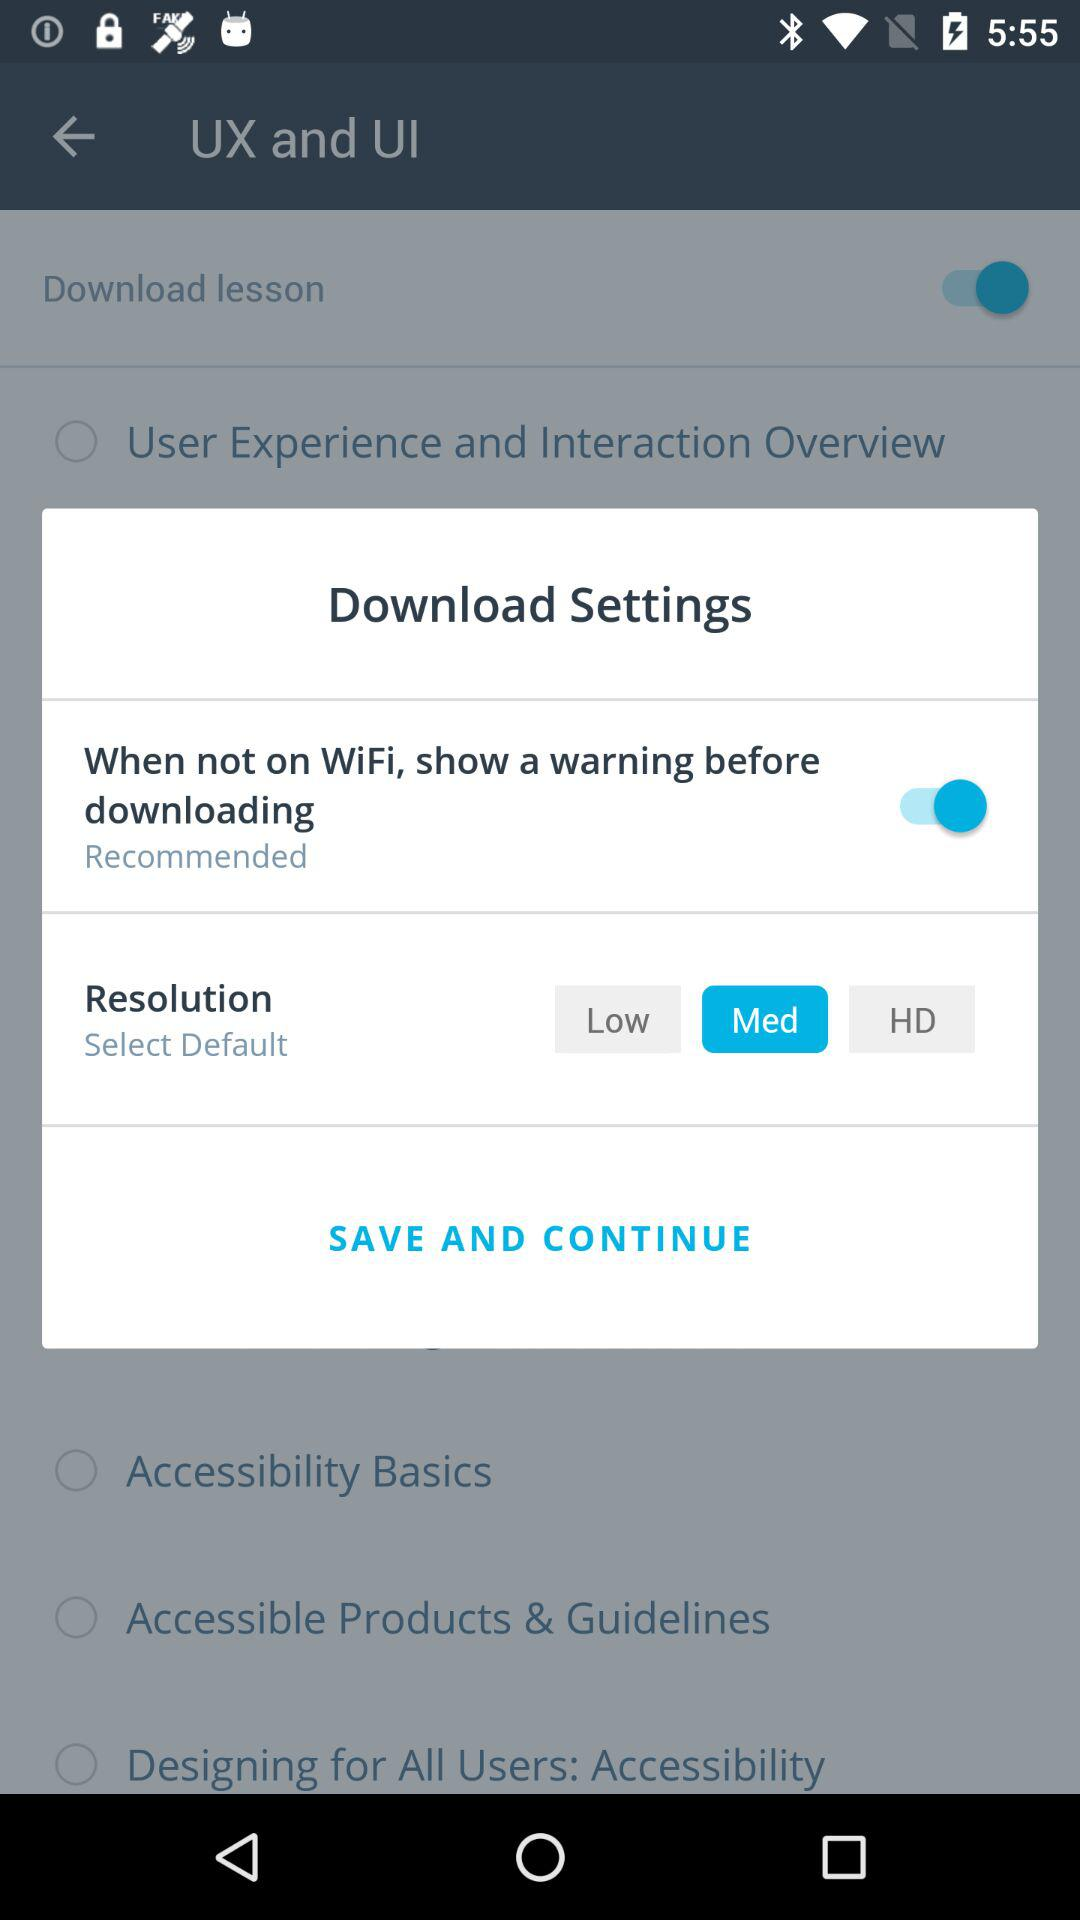Which resolution setting is selected? The selected resolution setting is "Med". 